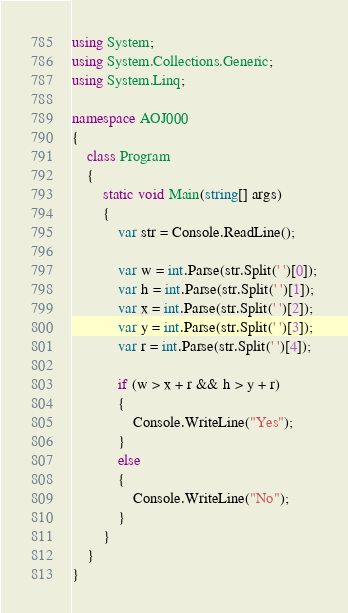<code> <loc_0><loc_0><loc_500><loc_500><_C#_>using System;
using System.Collections.Generic;
using System.Linq;

namespace AOJ000
{
    class Program
    {
        static void Main(string[] args)
        {
            var str = Console.ReadLine();

            var w = int.Parse(str.Split(' ')[0]);
            var h = int.Parse(str.Split(' ')[1]);
            var x = int.Parse(str.Split(' ')[2]);
            var y = int.Parse(str.Split(' ')[3]);
            var r = int.Parse(str.Split(' ')[4]);

            if (w > x + r && h > y + r)
            {
                Console.WriteLine("Yes");
            }
            else
            {
                Console.WriteLine("No");
            }
        }
    }
}</code> 